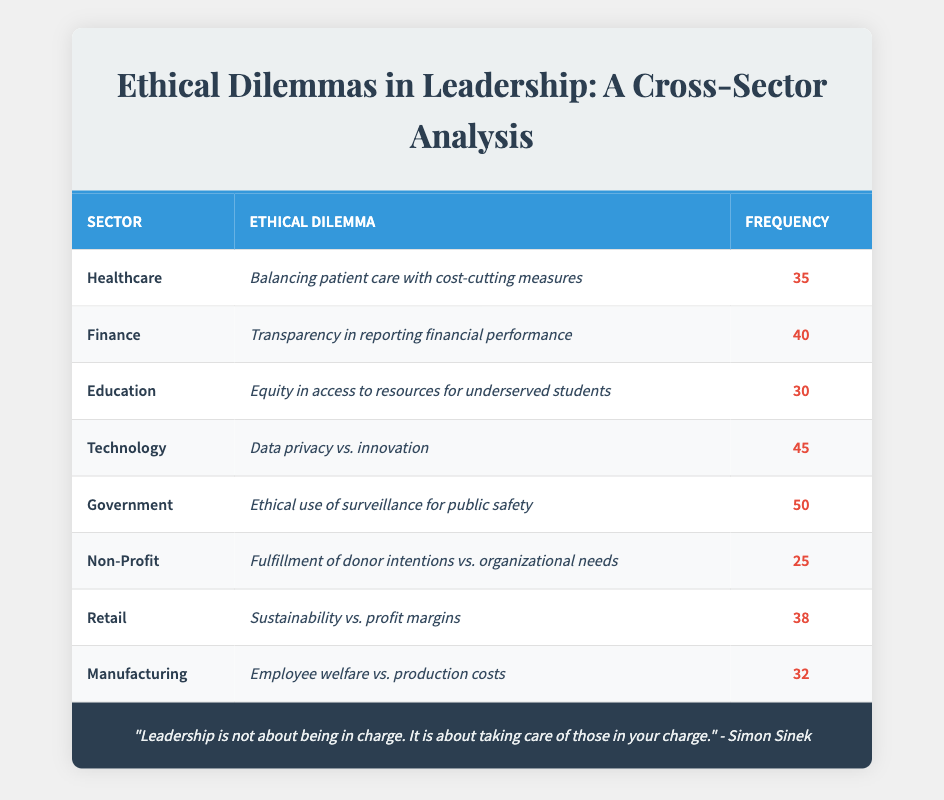What is the ethical dilemma faced by leaders in the Government sector? The table indicates that the ethical dilemma faced by leaders in the Government sector is "Ethical use of surveillance for public safety." This is directly retrieved from the corresponding row in the table.
Answer: Ethical use of surveillance for public safety Which sector has the highest frequency of ethical dilemmas reported? By examining the frequency values in the table, we find that the Government sector has a frequency of 50, which is higher than any other sector listed.
Answer: Government What is the total frequency of ethical dilemmas faced in the Healthcare and Education sectors combined? To find the total frequency, we need to add the frequencies of the Healthcare (35) and Education (30) sectors together: 35 + 30 = 65.
Answer: 65 Is it true that the Technology sector has a dilemma related to sustainability? The table shows that the dilemma facing the Technology sector is "Data privacy vs. innovation," which does not relate to sustainability. Thus, the statement is false.
Answer: No What is the average frequency of ethical dilemmas across all sectors listed in the table? To calculate the average frequency, we first sum all the frequencies: 35 (Healthcare) + 40 (Finance) + 30 (Education) + 45 (Technology) + 50 (Government) + 25 (Non-Profit) + 38 (Retail) + 32 (Manufacturing) = 345. We then divide this sum by the number of sectors, which is 8: 345 / 8 = 43.125.
Answer: 43.125 Which sector’s ethical dilemma focuses on employee welfare? The table reveals that the Manufacturing sector faces the dilemma "Employee welfare vs. production costs," which specifically addresses employee welfare.
Answer: Manufacturing What is the difference in frequency between the highest and lowest ethical dilemmas among all sectors? The highest frequency is reported in the Government sector (50), and the lowest is in the Non-Profit sector (25). The difference is calculated as 50 - 25 = 25.
Answer: 25 How many sectors report a frequency of ethical dilemmas above 30? Looking through the frequency values, the sectors with frequencies above 30 are Healthcare (35), Finance (40), Technology (45), Government (50), Retail (38), and Manufacturing (32). This includes 6 sectors in total.
Answer: 6 